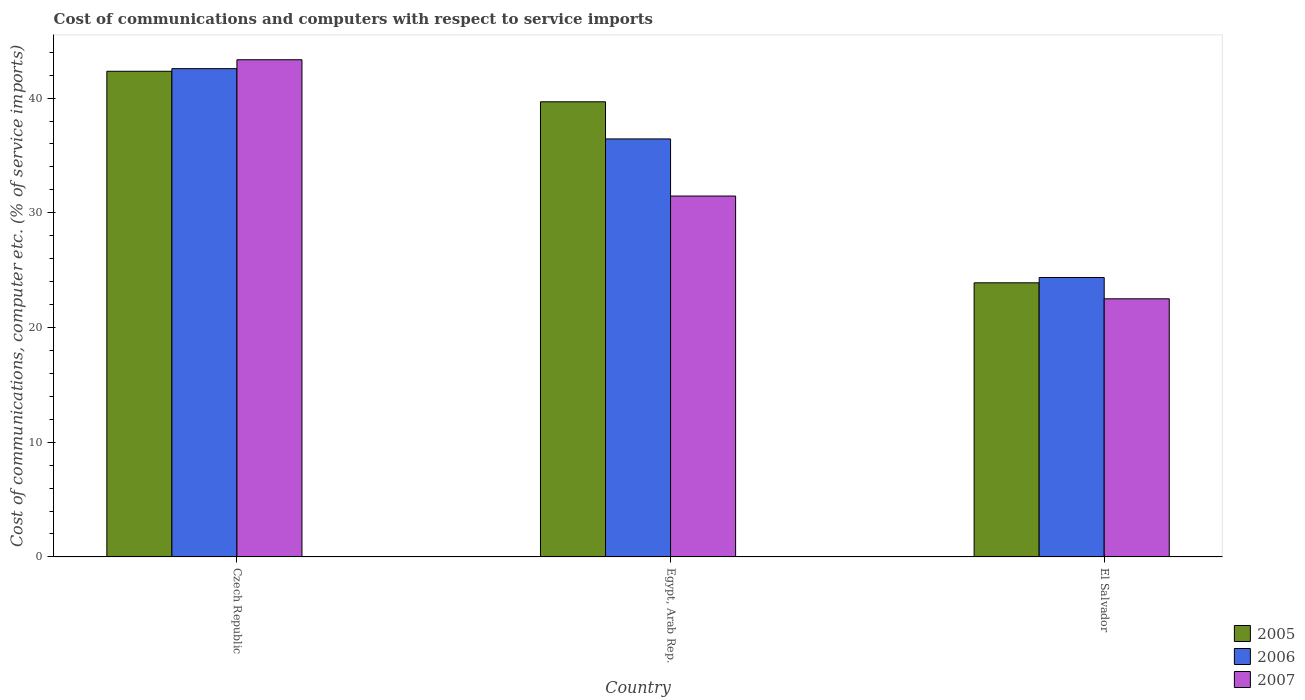How many different coloured bars are there?
Make the answer very short. 3. Are the number of bars per tick equal to the number of legend labels?
Offer a very short reply. Yes. Are the number of bars on each tick of the X-axis equal?
Keep it short and to the point. Yes. How many bars are there on the 2nd tick from the left?
Provide a short and direct response. 3. What is the label of the 2nd group of bars from the left?
Your response must be concise. Egypt, Arab Rep. What is the cost of communications and computers in 2007 in Egypt, Arab Rep.?
Make the answer very short. 31.46. Across all countries, what is the maximum cost of communications and computers in 2007?
Ensure brevity in your answer.  43.34. Across all countries, what is the minimum cost of communications and computers in 2006?
Provide a short and direct response. 24.36. In which country was the cost of communications and computers in 2007 maximum?
Make the answer very short. Czech Republic. In which country was the cost of communications and computers in 2005 minimum?
Offer a very short reply. El Salvador. What is the total cost of communications and computers in 2005 in the graph?
Your answer should be compact. 105.91. What is the difference between the cost of communications and computers in 2005 in Czech Republic and that in El Salvador?
Offer a very short reply. 18.44. What is the difference between the cost of communications and computers in 2007 in Egypt, Arab Rep. and the cost of communications and computers in 2006 in Czech Republic?
Keep it short and to the point. -11.1. What is the average cost of communications and computers in 2007 per country?
Keep it short and to the point. 32.43. What is the difference between the cost of communications and computers of/in 2005 and cost of communications and computers of/in 2006 in Czech Republic?
Your response must be concise. -0.23. In how many countries, is the cost of communications and computers in 2006 greater than 36 %?
Provide a succinct answer. 2. What is the ratio of the cost of communications and computers in 2007 in Czech Republic to that in El Salvador?
Make the answer very short. 1.93. What is the difference between the highest and the second highest cost of communications and computers in 2006?
Provide a succinct answer. -18.21. What is the difference between the highest and the lowest cost of communications and computers in 2005?
Give a very brief answer. 18.44. Is the sum of the cost of communications and computers in 2005 in Czech Republic and Egypt, Arab Rep. greater than the maximum cost of communications and computers in 2006 across all countries?
Offer a terse response. Yes. What does the 1st bar from the right in Egypt, Arab Rep. represents?
Offer a terse response. 2007. Is it the case that in every country, the sum of the cost of communications and computers in 2006 and cost of communications and computers in 2005 is greater than the cost of communications and computers in 2007?
Keep it short and to the point. Yes. Are all the bars in the graph horizontal?
Your response must be concise. No. How many countries are there in the graph?
Give a very brief answer. 3. Does the graph contain grids?
Make the answer very short. No. How are the legend labels stacked?
Make the answer very short. Vertical. What is the title of the graph?
Offer a very short reply. Cost of communications and computers with respect to service imports. Does "1989" appear as one of the legend labels in the graph?
Ensure brevity in your answer.  No. What is the label or title of the Y-axis?
Ensure brevity in your answer.  Cost of communications, computer etc. (% of service imports). What is the Cost of communications, computer etc. (% of service imports) of 2005 in Czech Republic?
Make the answer very short. 42.33. What is the Cost of communications, computer etc. (% of service imports) in 2006 in Czech Republic?
Your answer should be compact. 42.56. What is the Cost of communications, computer etc. (% of service imports) of 2007 in Czech Republic?
Provide a short and direct response. 43.34. What is the Cost of communications, computer etc. (% of service imports) of 2005 in Egypt, Arab Rep.?
Provide a succinct answer. 39.68. What is the Cost of communications, computer etc. (% of service imports) of 2006 in Egypt, Arab Rep.?
Your answer should be very brief. 36.44. What is the Cost of communications, computer etc. (% of service imports) in 2007 in Egypt, Arab Rep.?
Offer a very short reply. 31.46. What is the Cost of communications, computer etc. (% of service imports) in 2005 in El Salvador?
Give a very brief answer. 23.9. What is the Cost of communications, computer etc. (% of service imports) of 2006 in El Salvador?
Keep it short and to the point. 24.36. What is the Cost of communications, computer etc. (% of service imports) in 2007 in El Salvador?
Ensure brevity in your answer.  22.5. Across all countries, what is the maximum Cost of communications, computer etc. (% of service imports) in 2005?
Give a very brief answer. 42.33. Across all countries, what is the maximum Cost of communications, computer etc. (% of service imports) in 2006?
Keep it short and to the point. 42.56. Across all countries, what is the maximum Cost of communications, computer etc. (% of service imports) in 2007?
Your answer should be compact. 43.34. Across all countries, what is the minimum Cost of communications, computer etc. (% of service imports) of 2005?
Your response must be concise. 23.9. Across all countries, what is the minimum Cost of communications, computer etc. (% of service imports) in 2006?
Keep it short and to the point. 24.36. Across all countries, what is the minimum Cost of communications, computer etc. (% of service imports) in 2007?
Ensure brevity in your answer.  22.5. What is the total Cost of communications, computer etc. (% of service imports) in 2005 in the graph?
Offer a very short reply. 105.91. What is the total Cost of communications, computer etc. (% of service imports) in 2006 in the graph?
Your response must be concise. 103.36. What is the total Cost of communications, computer etc. (% of service imports) in 2007 in the graph?
Make the answer very short. 97.3. What is the difference between the Cost of communications, computer etc. (% of service imports) in 2005 in Czech Republic and that in Egypt, Arab Rep.?
Keep it short and to the point. 2.66. What is the difference between the Cost of communications, computer etc. (% of service imports) in 2006 in Czech Republic and that in Egypt, Arab Rep.?
Keep it short and to the point. 6.13. What is the difference between the Cost of communications, computer etc. (% of service imports) of 2007 in Czech Republic and that in Egypt, Arab Rep.?
Give a very brief answer. 11.88. What is the difference between the Cost of communications, computer etc. (% of service imports) of 2005 in Czech Republic and that in El Salvador?
Provide a short and direct response. 18.44. What is the difference between the Cost of communications, computer etc. (% of service imports) in 2006 in Czech Republic and that in El Salvador?
Offer a very short reply. 18.21. What is the difference between the Cost of communications, computer etc. (% of service imports) of 2007 in Czech Republic and that in El Salvador?
Offer a terse response. 20.84. What is the difference between the Cost of communications, computer etc. (% of service imports) in 2005 in Egypt, Arab Rep. and that in El Salvador?
Your response must be concise. 15.78. What is the difference between the Cost of communications, computer etc. (% of service imports) of 2006 in Egypt, Arab Rep. and that in El Salvador?
Keep it short and to the point. 12.08. What is the difference between the Cost of communications, computer etc. (% of service imports) in 2007 in Egypt, Arab Rep. and that in El Salvador?
Give a very brief answer. 8.96. What is the difference between the Cost of communications, computer etc. (% of service imports) in 2005 in Czech Republic and the Cost of communications, computer etc. (% of service imports) in 2006 in Egypt, Arab Rep.?
Provide a short and direct response. 5.9. What is the difference between the Cost of communications, computer etc. (% of service imports) in 2005 in Czech Republic and the Cost of communications, computer etc. (% of service imports) in 2007 in Egypt, Arab Rep.?
Ensure brevity in your answer.  10.88. What is the difference between the Cost of communications, computer etc. (% of service imports) in 2006 in Czech Republic and the Cost of communications, computer etc. (% of service imports) in 2007 in Egypt, Arab Rep.?
Keep it short and to the point. 11.1. What is the difference between the Cost of communications, computer etc. (% of service imports) in 2005 in Czech Republic and the Cost of communications, computer etc. (% of service imports) in 2006 in El Salvador?
Give a very brief answer. 17.98. What is the difference between the Cost of communications, computer etc. (% of service imports) in 2005 in Czech Republic and the Cost of communications, computer etc. (% of service imports) in 2007 in El Salvador?
Give a very brief answer. 19.83. What is the difference between the Cost of communications, computer etc. (% of service imports) in 2006 in Czech Republic and the Cost of communications, computer etc. (% of service imports) in 2007 in El Salvador?
Ensure brevity in your answer.  20.06. What is the difference between the Cost of communications, computer etc. (% of service imports) in 2005 in Egypt, Arab Rep. and the Cost of communications, computer etc. (% of service imports) in 2006 in El Salvador?
Make the answer very short. 15.32. What is the difference between the Cost of communications, computer etc. (% of service imports) of 2005 in Egypt, Arab Rep. and the Cost of communications, computer etc. (% of service imports) of 2007 in El Salvador?
Your answer should be very brief. 17.17. What is the difference between the Cost of communications, computer etc. (% of service imports) in 2006 in Egypt, Arab Rep. and the Cost of communications, computer etc. (% of service imports) in 2007 in El Salvador?
Keep it short and to the point. 13.94. What is the average Cost of communications, computer etc. (% of service imports) of 2005 per country?
Ensure brevity in your answer.  35.3. What is the average Cost of communications, computer etc. (% of service imports) in 2006 per country?
Make the answer very short. 34.45. What is the average Cost of communications, computer etc. (% of service imports) in 2007 per country?
Your answer should be compact. 32.43. What is the difference between the Cost of communications, computer etc. (% of service imports) in 2005 and Cost of communications, computer etc. (% of service imports) in 2006 in Czech Republic?
Your response must be concise. -0.23. What is the difference between the Cost of communications, computer etc. (% of service imports) of 2005 and Cost of communications, computer etc. (% of service imports) of 2007 in Czech Republic?
Give a very brief answer. -1.01. What is the difference between the Cost of communications, computer etc. (% of service imports) of 2006 and Cost of communications, computer etc. (% of service imports) of 2007 in Czech Republic?
Offer a very short reply. -0.78. What is the difference between the Cost of communications, computer etc. (% of service imports) of 2005 and Cost of communications, computer etc. (% of service imports) of 2006 in Egypt, Arab Rep.?
Give a very brief answer. 3.24. What is the difference between the Cost of communications, computer etc. (% of service imports) in 2005 and Cost of communications, computer etc. (% of service imports) in 2007 in Egypt, Arab Rep.?
Ensure brevity in your answer.  8.22. What is the difference between the Cost of communications, computer etc. (% of service imports) of 2006 and Cost of communications, computer etc. (% of service imports) of 2007 in Egypt, Arab Rep.?
Provide a succinct answer. 4.98. What is the difference between the Cost of communications, computer etc. (% of service imports) in 2005 and Cost of communications, computer etc. (% of service imports) in 2006 in El Salvador?
Make the answer very short. -0.46. What is the difference between the Cost of communications, computer etc. (% of service imports) of 2005 and Cost of communications, computer etc. (% of service imports) of 2007 in El Salvador?
Keep it short and to the point. 1.39. What is the difference between the Cost of communications, computer etc. (% of service imports) of 2006 and Cost of communications, computer etc. (% of service imports) of 2007 in El Salvador?
Your response must be concise. 1.86. What is the ratio of the Cost of communications, computer etc. (% of service imports) of 2005 in Czech Republic to that in Egypt, Arab Rep.?
Your answer should be very brief. 1.07. What is the ratio of the Cost of communications, computer etc. (% of service imports) in 2006 in Czech Republic to that in Egypt, Arab Rep.?
Keep it short and to the point. 1.17. What is the ratio of the Cost of communications, computer etc. (% of service imports) of 2007 in Czech Republic to that in Egypt, Arab Rep.?
Your answer should be compact. 1.38. What is the ratio of the Cost of communications, computer etc. (% of service imports) of 2005 in Czech Republic to that in El Salvador?
Offer a terse response. 1.77. What is the ratio of the Cost of communications, computer etc. (% of service imports) of 2006 in Czech Republic to that in El Salvador?
Keep it short and to the point. 1.75. What is the ratio of the Cost of communications, computer etc. (% of service imports) of 2007 in Czech Republic to that in El Salvador?
Provide a succinct answer. 1.93. What is the ratio of the Cost of communications, computer etc. (% of service imports) in 2005 in Egypt, Arab Rep. to that in El Salvador?
Offer a terse response. 1.66. What is the ratio of the Cost of communications, computer etc. (% of service imports) of 2006 in Egypt, Arab Rep. to that in El Salvador?
Your response must be concise. 1.5. What is the ratio of the Cost of communications, computer etc. (% of service imports) in 2007 in Egypt, Arab Rep. to that in El Salvador?
Offer a very short reply. 1.4. What is the difference between the highest and the second highest Cost of communications, computer etc. (% of service imports) of 2005?
Ensure brevity in your answer.  2.66. What is the difference between the highest and the second highest Cost of communications, computer etc. (% of service imports) of 2006?
Provide a short and direct response. 6.13. What is the difference between the highest and the second highest Cost of communications, computer etc. (% of service imports) in 2007?
Ensure brevity in your answer.  11.88. What is the difference between the highest and the lowest Cost of communications, computer etc. (% of service imports) of 2005?
Provide a short and direct response. 18.44. What is the difference between the highest and the lowest Cost of communications, computer etc. (% of service imports) in 2006?
Provide a short and direct response. 18.21. What is the difference between the highest and the lowest Cost of communications, computer etc. (% of service imports) in 2007?
Give a very brief answer. 20.84. 